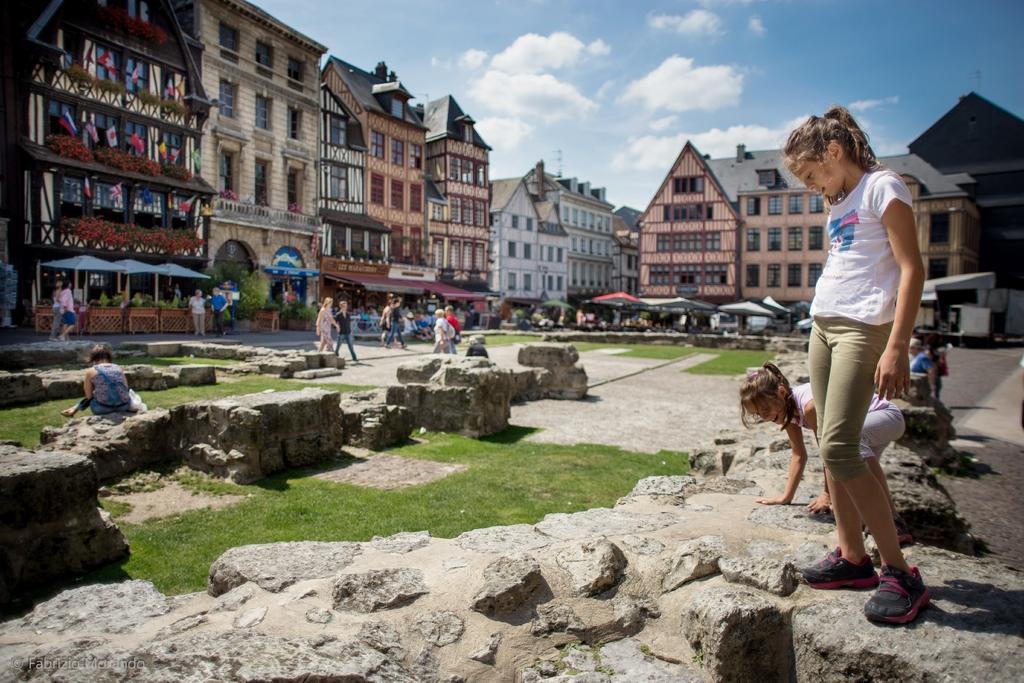Describe this image in one or two sentences. In the picture we can see a rock surface on it we can see two girls, one girl is standing and one girl is bending and in front of them we can see some grass surface and some rocks and far away from it we can see some people are walking on the path and behind them we can see some buildings with windows and behind it we can see a sky. 